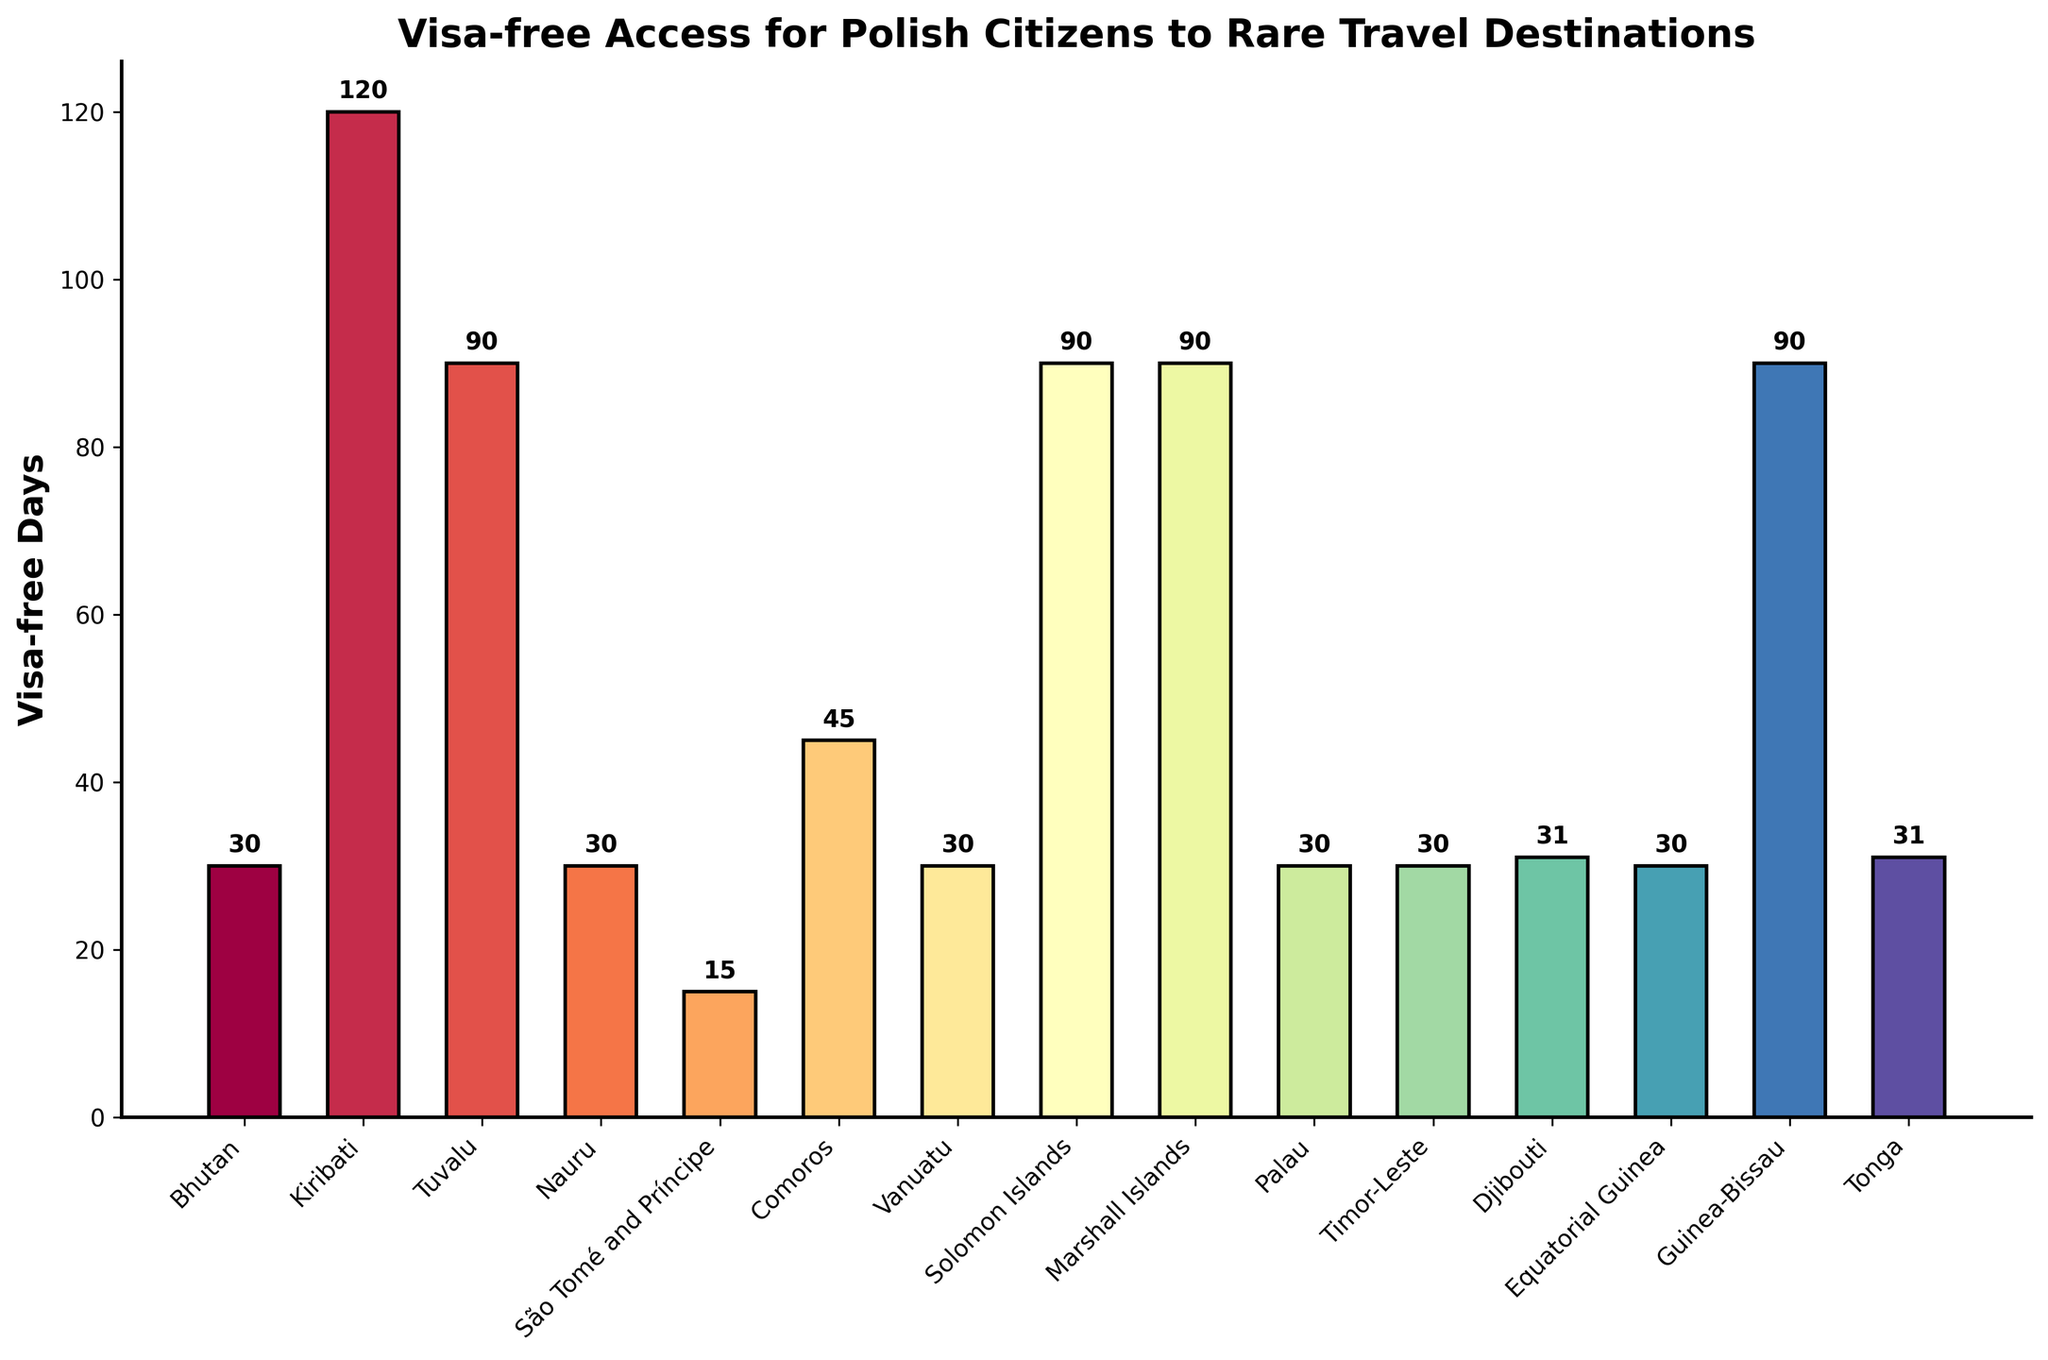Which country allows Polish citizens the highest number of visa-free days? By observing the bar chart, the bar representing Kiribati is the tallest among all, indicating that Kiribati allows the highest number of visa-free days.
Answer: Kiribati Which country allows Polish citizens the lowest number of visa-free days? By noting the shortest bar, the data shows that São Tomé and Príncipe offers the fewest visa-free days.
Answer: São Tomé and Príncipe How many days in total can Polish citizens stay visa-free in Tuvalu, Nauru, Comoros, and Vanuatu combined? The visa-free days are Tuvalu (90), Nauru (30), Comoros (45), and Vanuatu (30). Summing them: 90 + 30 + 45 + 30 = 195 days.
Answer: 195 days Which countries allow Polish citizens to stay visa-free for exactly 30 days? Observing the bars with a height corresponding to 30 days, we see Bhutan, Nauru, Vanuatu, Palau, Timor-Leste, and Equatorial Guinea.
Answer: Bhutan, Nauru, Vanuatu, Palau, Timor-Leste, Equatorial Guinea What is the difference in visa-free days between Comoros and Djibouti? Comoros allows 45 days, and Djibouti allows 31 days. The difference between these is 45 - 31 = 14 days.
Answer: 14 days In terms of visa-free days, how does the stay length in Solomon Islands compare to that in Tonga? The visa-free stays in Solomon Islands and Tonga are both represented as high bars. Solomon Islands allows 90 days, and Tonga allows 31 days. Comparing these, Solomon Islands offers 59 more days than Tonga (90 - 31 = 59).
Answer: 59 days more Which countries allow a visa-free stay of fewer than 30 days? By looking for the shortest bars, São Tomé and Príncipe (15 days) and Djibouti (31 days) fit this criterion. However, only São Tomé and Príncipe is under 30 days.
Answer: São Tomé and Príncipe 